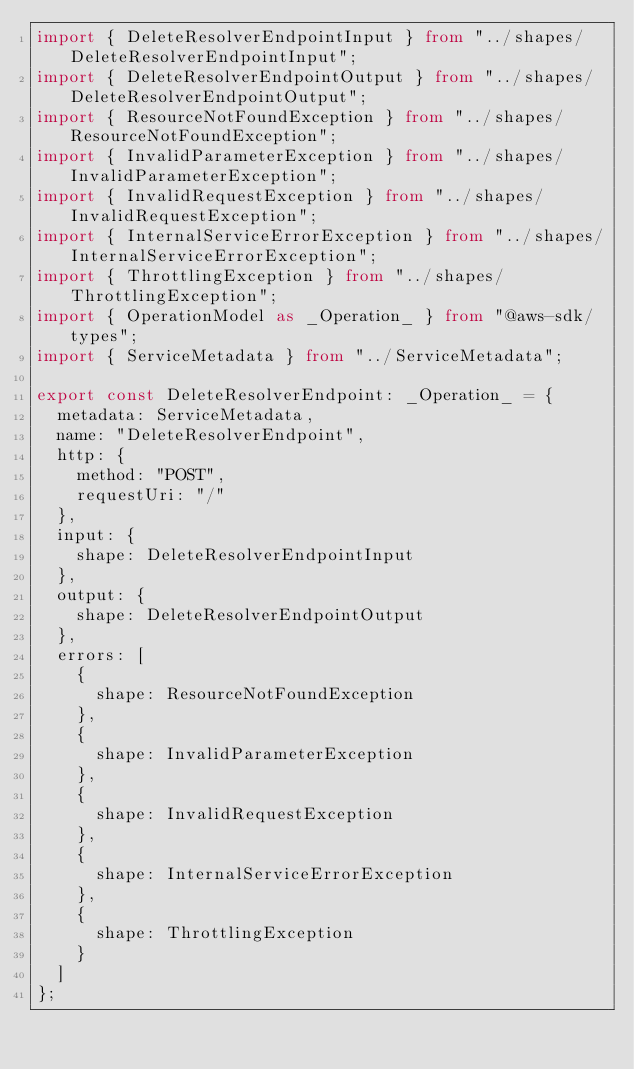<code> <loc_0><loc_0><loc_500><loc_500><_TypeScript_>import { DeleteResolverEndpointInput } from "../shapes/DeleteResolverEndpointInput";
import { DeleteResolverEndpointOutput } from "../shapes/DeleteResolverEndpointOutput";
import { ResourceNotFoundException } from "../shapes/ResourceNotFoundException";
import { InvalidParameterException } from "../shapes/InvalidParameterException";
import { InvalidRequestException } from "../shapes/InvalidRequestException";
import { InternalServiceErrorException } from "../shapes/InternalServiceErrorException";
import { ThrottlingException } from "../shapes/ThrottlingException";
import { OperationModel as _Operation_ } from "@aws-sdk/types";
import { ServiceMetadata } from "../ServiceMetadata";

export const DeleteResolverEndpoint: _Operation_ = {
  metadata: ServiceMetadata,
  name: "DeleteResolverEndpoint",
  http: {
    method: "POST",
    requestUri: "/"
  },
  input: {
    shape: DeleteResolverEndpointInput
  },
  output: {
    shape: DeleteResolverEndpointOutput
  },
  errors: [
    {
      shape: ResourceNotFoundException
    },
    {
      shape: InvalidParameterException
    },
    {
      shape: InvalidRequestException
    },
    {
      shape: InternalServiceErrorException
    },
    {
      shape: ThrottlingException
    }
  ]
};
</code> 